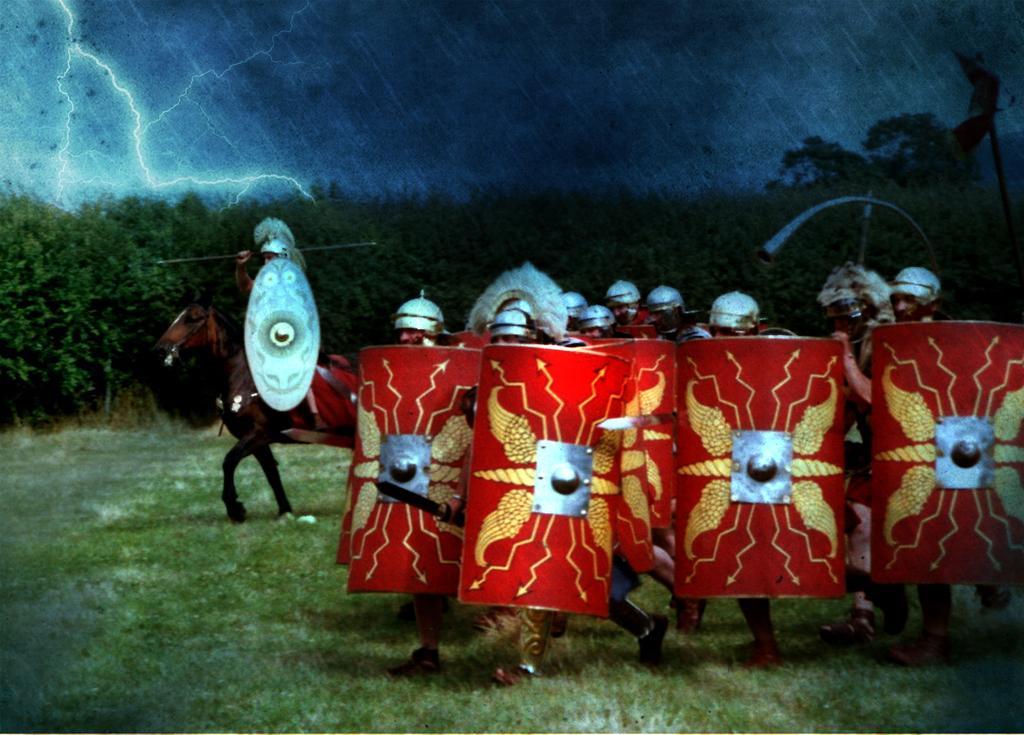How would you summarize this image in a sentence or two? This is an edited image, we can see a man is sitting on a horse and on the path there are groups of people standing and holding the shields. Behind the people there are trees and a cloudy sky and in the sky there is a thunder. 